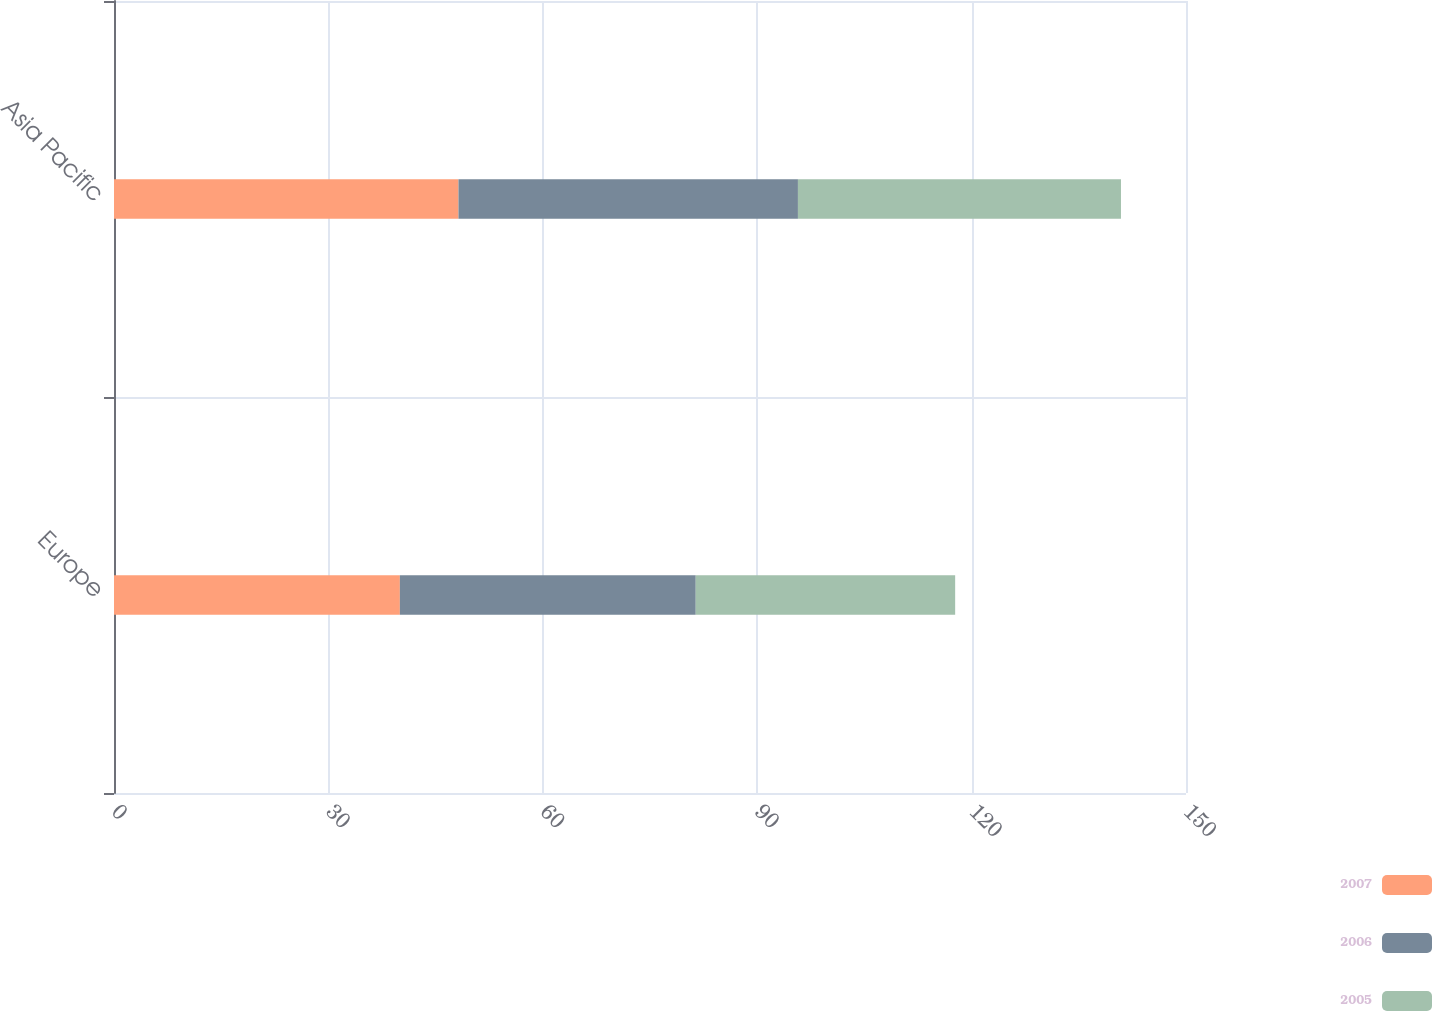<chart> <loc_0><loc_0><loc_500><loc_500><stacked_bar_chart><ecel><fcel>Europe<fcel>Asia Pacific<nl><fcel>2007<fcel>40<fcel>48.2<nl><fcel>2006<fcel>41.4<fcel>47.5<nl><fcel>2005<fcel>36.3<fcel>45.2<nl></chart> 